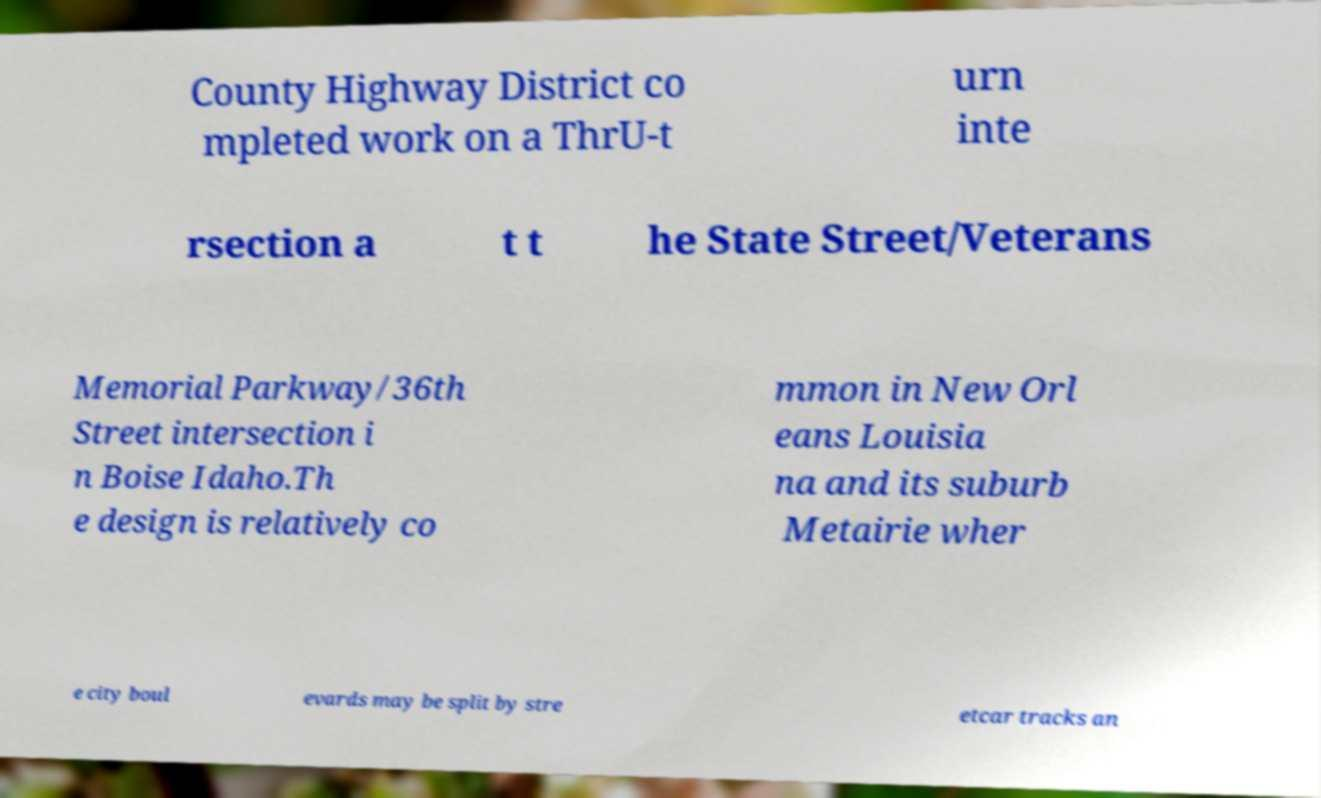Could you assist in decoding the text presented in this image and type it out clearly? County Highway District co mpleted work on a ThrU-t urn inte rsection a t t he State Street/Veterans Memorial Parkway/36th Street intersection i n Boise Idaho.Th e design is relatively co mmon in New Orl eans Louisia na and its suburb Metairie wher e city boul evards may be split by stre etcar tracks an 